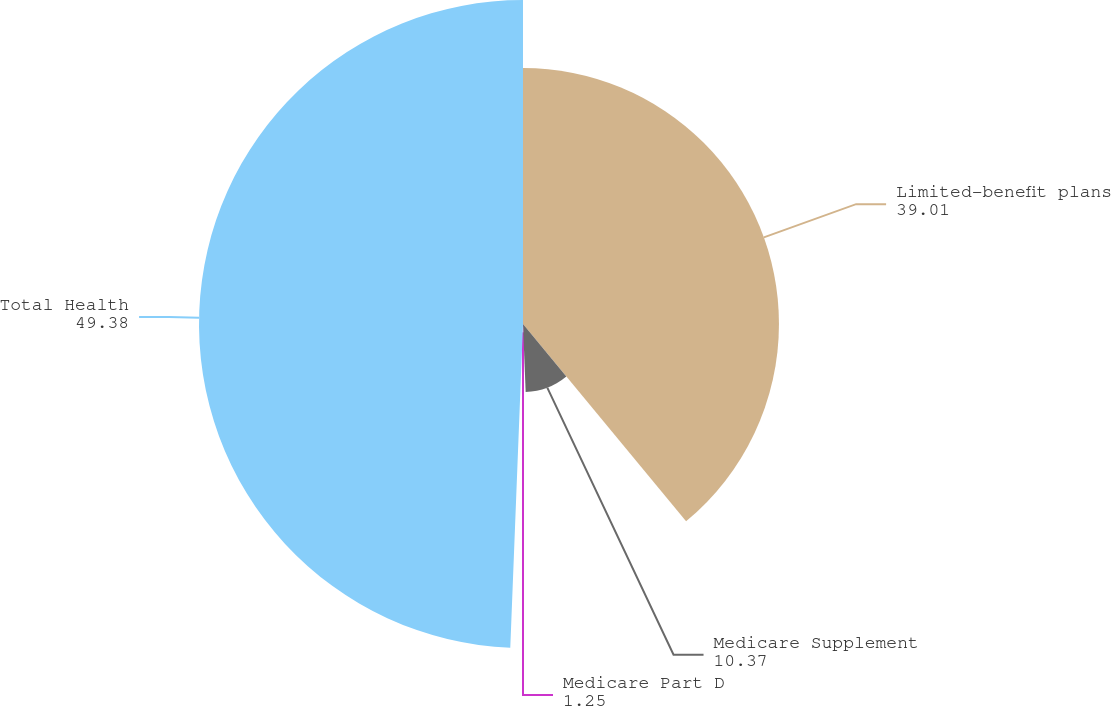Convert chart to OTSL. <chart><loc_0><loc_0><loc_500><loc_500><pie_chart><fcel>Limited-benefit plans<fcel>Medicare Supplement<fcel>Medicare Part D<fcel>Total Health<nl><fcel>39.01%<fcel>10.37%<fcel>1.25%<fcel>49.38%<nl></chart> 